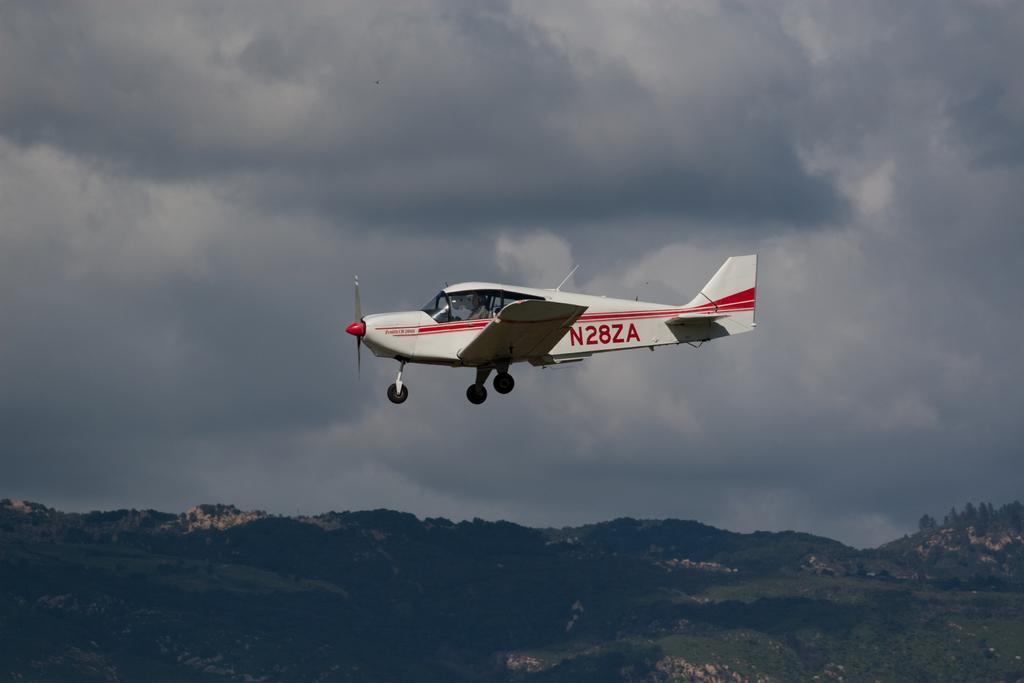Describe this image in one or two sentences. In this image we can see an aircraft flying, there are some mountains, trees and also we can see the sky with clouds. 